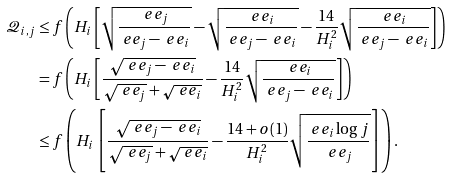Convert formula to latex. <formula><loc_0><loc_0><loc_500><loc_500>\mathcal { Q } _ { i , j } & \leq f \left ( H _ { i } \left [ \sqrt { \frac { \ e e _ { j } } { \ e e _ { j } - \ e e _ { i } } } - \sqrt { \frac { \ e e _ { i } } { \ e e _ { j } - \ e e _ { i } } } - \frac { 1 4 } { H _ { i } ^ { 2 } } \sqrt { \frac { \ e e _ { i } } { \ e e _ { j } - \ e e _ { i } } } \right ] \right ) \\ & = f \left ( H _ { i } \left [ \frac { \sqrt { \ e e _ { j } - \ e e _ { i } } } { \sqrt { \ e e _ { j } } + \sqrt { \ e e _ { i } } } - \frac { 1 4 } { H _ { i } ^ { 2 } } \sqrt { \frac { \ e e _ { i } } { \ e e _ { j } - \ e e _ { i } } } \right ] \right ) \\ & \leq f \left ( H _ { i } \left [ \frac { \sqrt { \ e e _ { j } - \ e e _ { i } } } { \sqrt { \ e e _ { j } } + \sqrt { \ e e _ { i } } } - \frac { 1 4 + o ( 1 ) } { H _ { i } ^ { 2 } } \sqrt { \frac { \ e e _ { i } \log j } { \ e e _ { j } } } \right ] \right ) .</formula> 